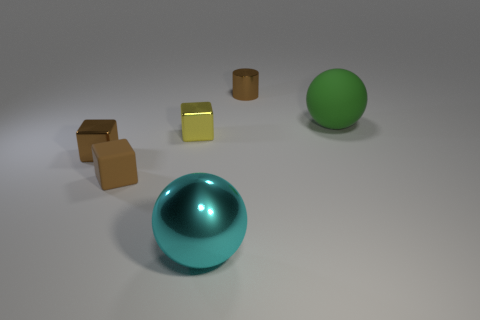Subtract all small brown rubber cubes. How many cubes are left? 2 Add 2 tiny brown metallic objects. How many objects exist? 8 Subtract all yellow cubes. How many cubes are left? 2 Subtract 1 balls. How many balls are left? 1 Subtract all small yellow metal things. Subtract all big cyan metallic cylinders. How many objects are left? 5 Add 2 tiny yellow blocks. How many tiny yellow blocks are left? 3 Add 3 small brown objects. How many small brown objects exist? 6 Subtract 0 blue spheres. How many objects are left? 6 Subtract all cylinders. How many objects are left? 5 Subtract all blue cylinders. Subtract all purple balls. How many cylinders are left? 1 